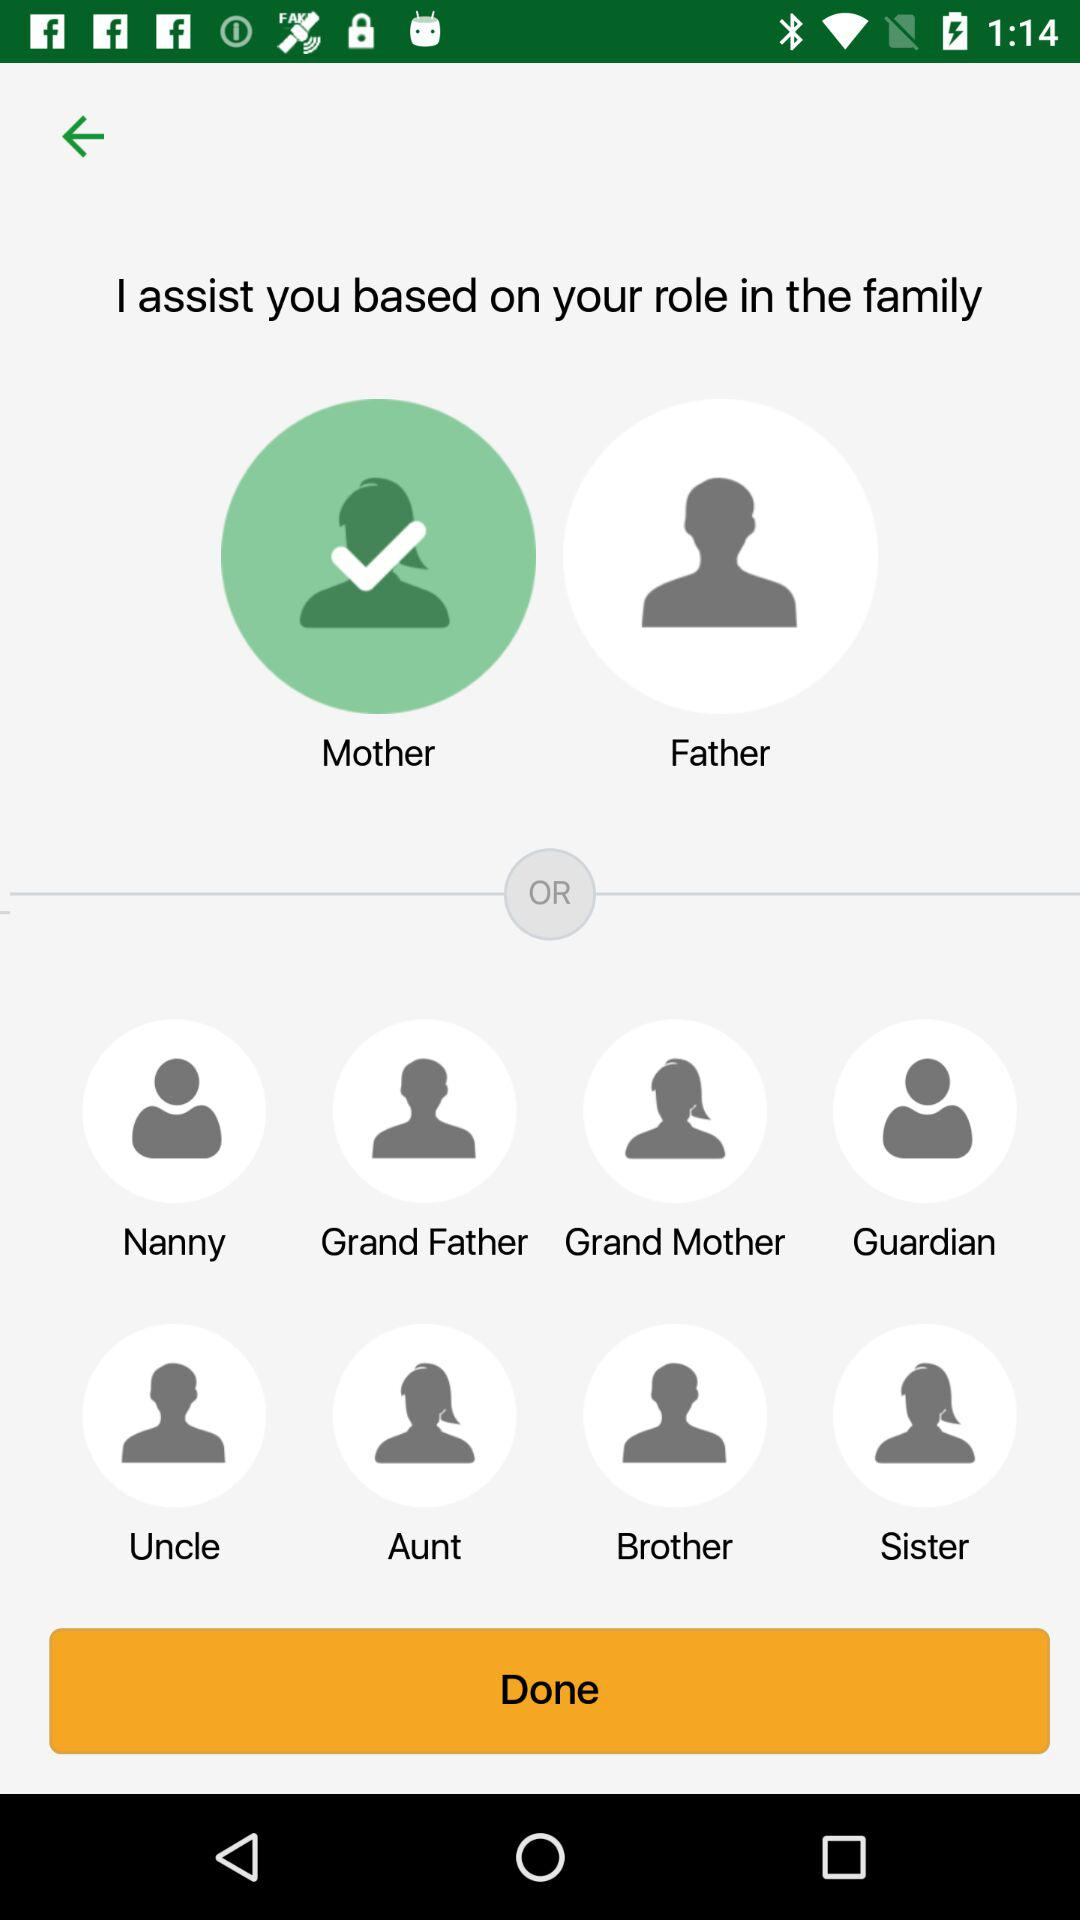Which option is selected? The selected option is "Mother". 